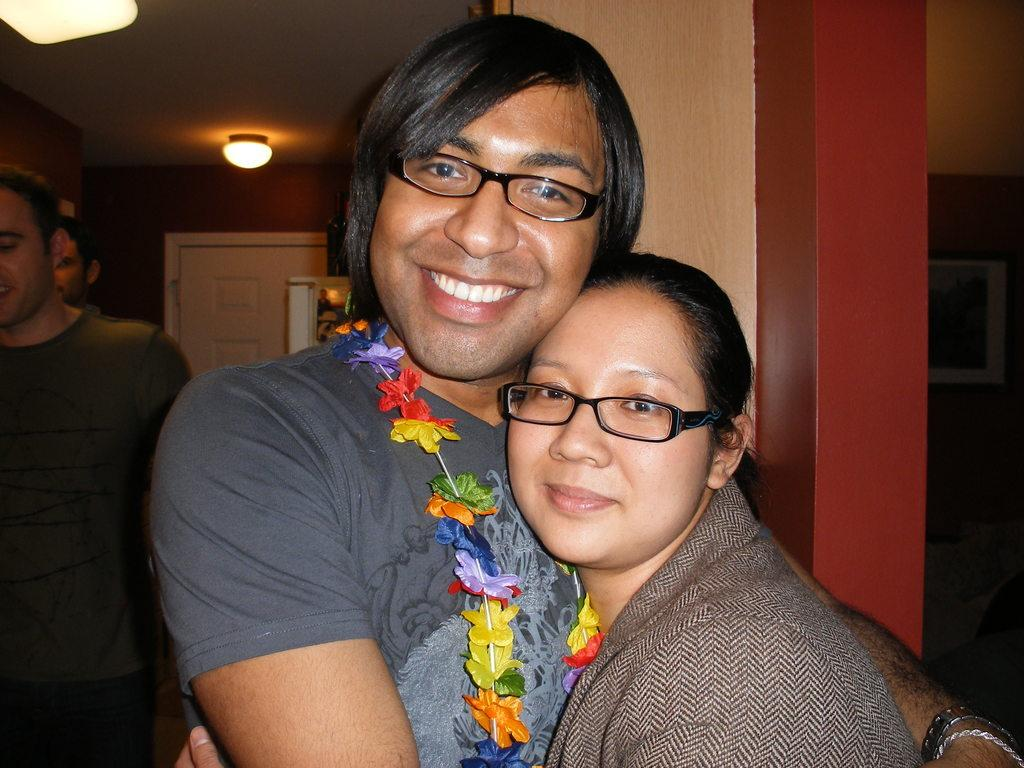Who are the main subjects in the image? There is a lady and a guy in the image. What are the lady and guy doing in the image? The lady and guy are holding each other. Can you describe the background of the image? There are other people in the background of the image. What is on the roof in the image? There is a light on the roof in the image. What type of transport can be seen in the image? There is no transport visible in the image. What team are the lady and guy supporting in the image? There is no indication of a team or any sports-related activity in the image. 